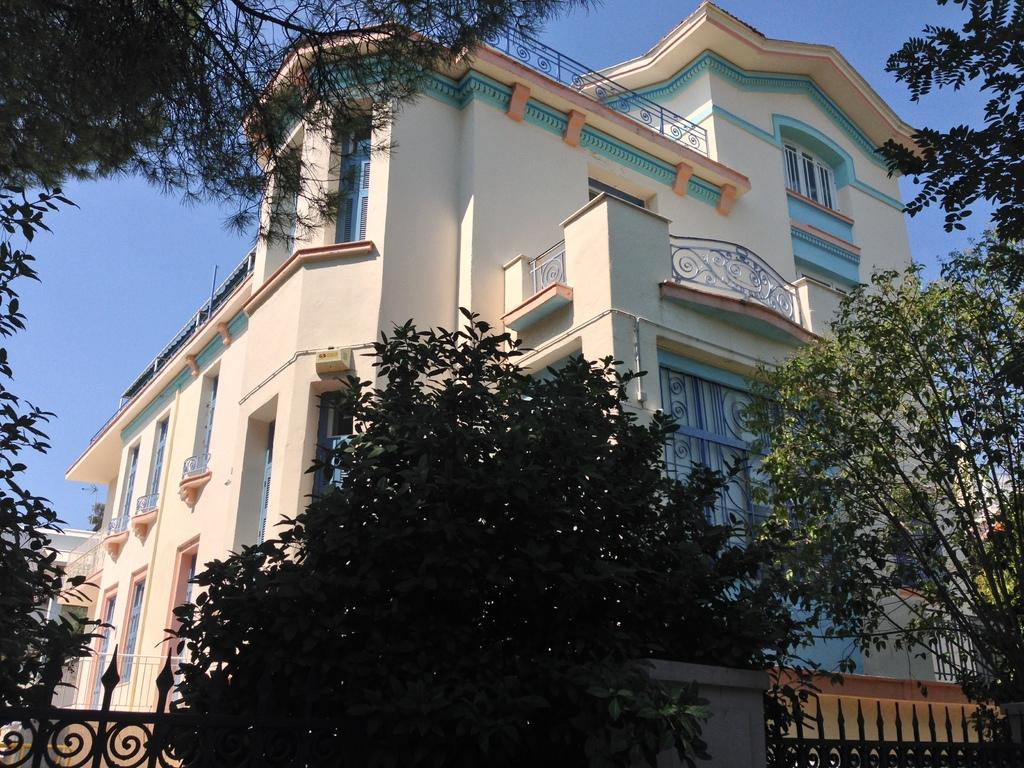What is the main subject in the center of the image? There is a building in the center of the image. What type of vegetation can be seen on the right side of the image? There are trees on the right side of the image. What type of vegetation can be seen on the left side of the image? There are trees on the left side of the image. What type of liquid can be seen flowing through the building in the image? There is no liquid flowing through the building in the image; it is a solid structure. 